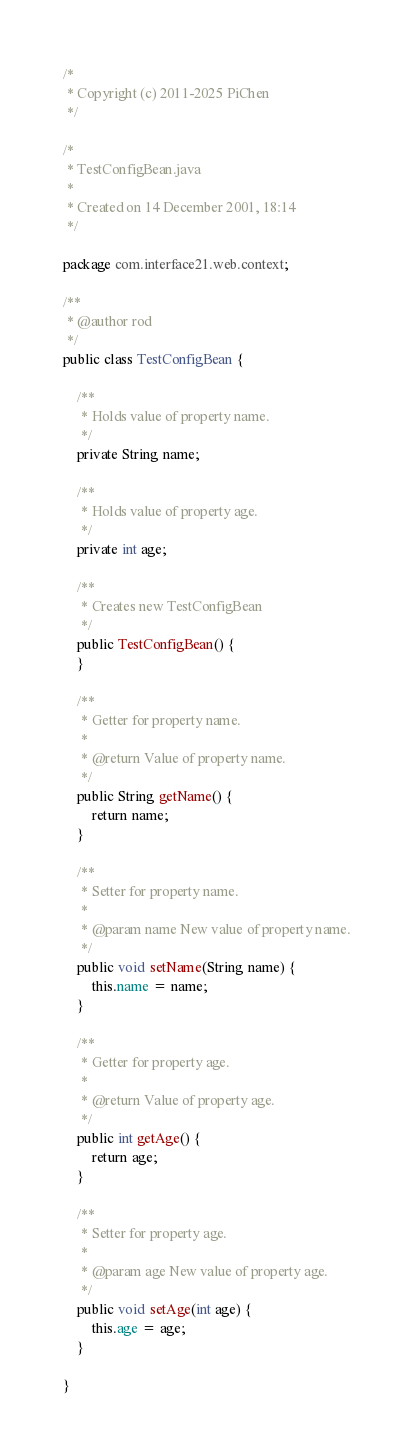Convert code to text. <code><loc_0><loc_0><loc_500><loc_500><_Java_>/*
 * Copyright (c) 2011-2025 PiChen
 */

/*
 * TestConfigBean.java
 *
 * Created on 14 December 2001, 18:14
 */

package com.interface21.web.context;

/**
 * @author rod
 */
public class TestConfigBean {

    /**
     * Holds value of property name.
     */
    private String name;

    /**
     * Holds value of property age.
     */
    private int age;

    /**
     * Creates new TestConfigBean
     */
    public TestConfigBean() {
    }

    /**
     * Getter for property name.
     *
     * @return Value of property name.
     */
    public String getName() {
        return name;
    }

    /**
     * Setter for property name.
     *
     * @param name New value of property name.
     */
    public void setName(String name) {
        this.name = name;
    }

    /**
     * Getter for property age.
     *
     * @return Value of property age.
     */
    public int getAge() {
        return age;
    }

    /**
     * Setter for property age.
     *
     * @param age New value of property age.
     */
    public void setAge(int age) {
        this.age = age;
    }

}
</code> 